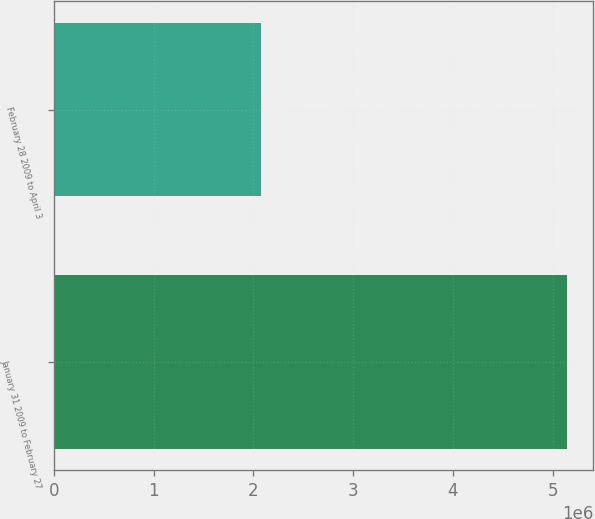Convert chart to OTSL. <chart><loc_0><loc_0><loc_500><loc_500><bar_chart><fcel>January 31 2009 to February 27<fcel>February 28 2009 to April 3<nl><fcel>5.1492e+06<fcel>2.0779e+06<nl></chart> 